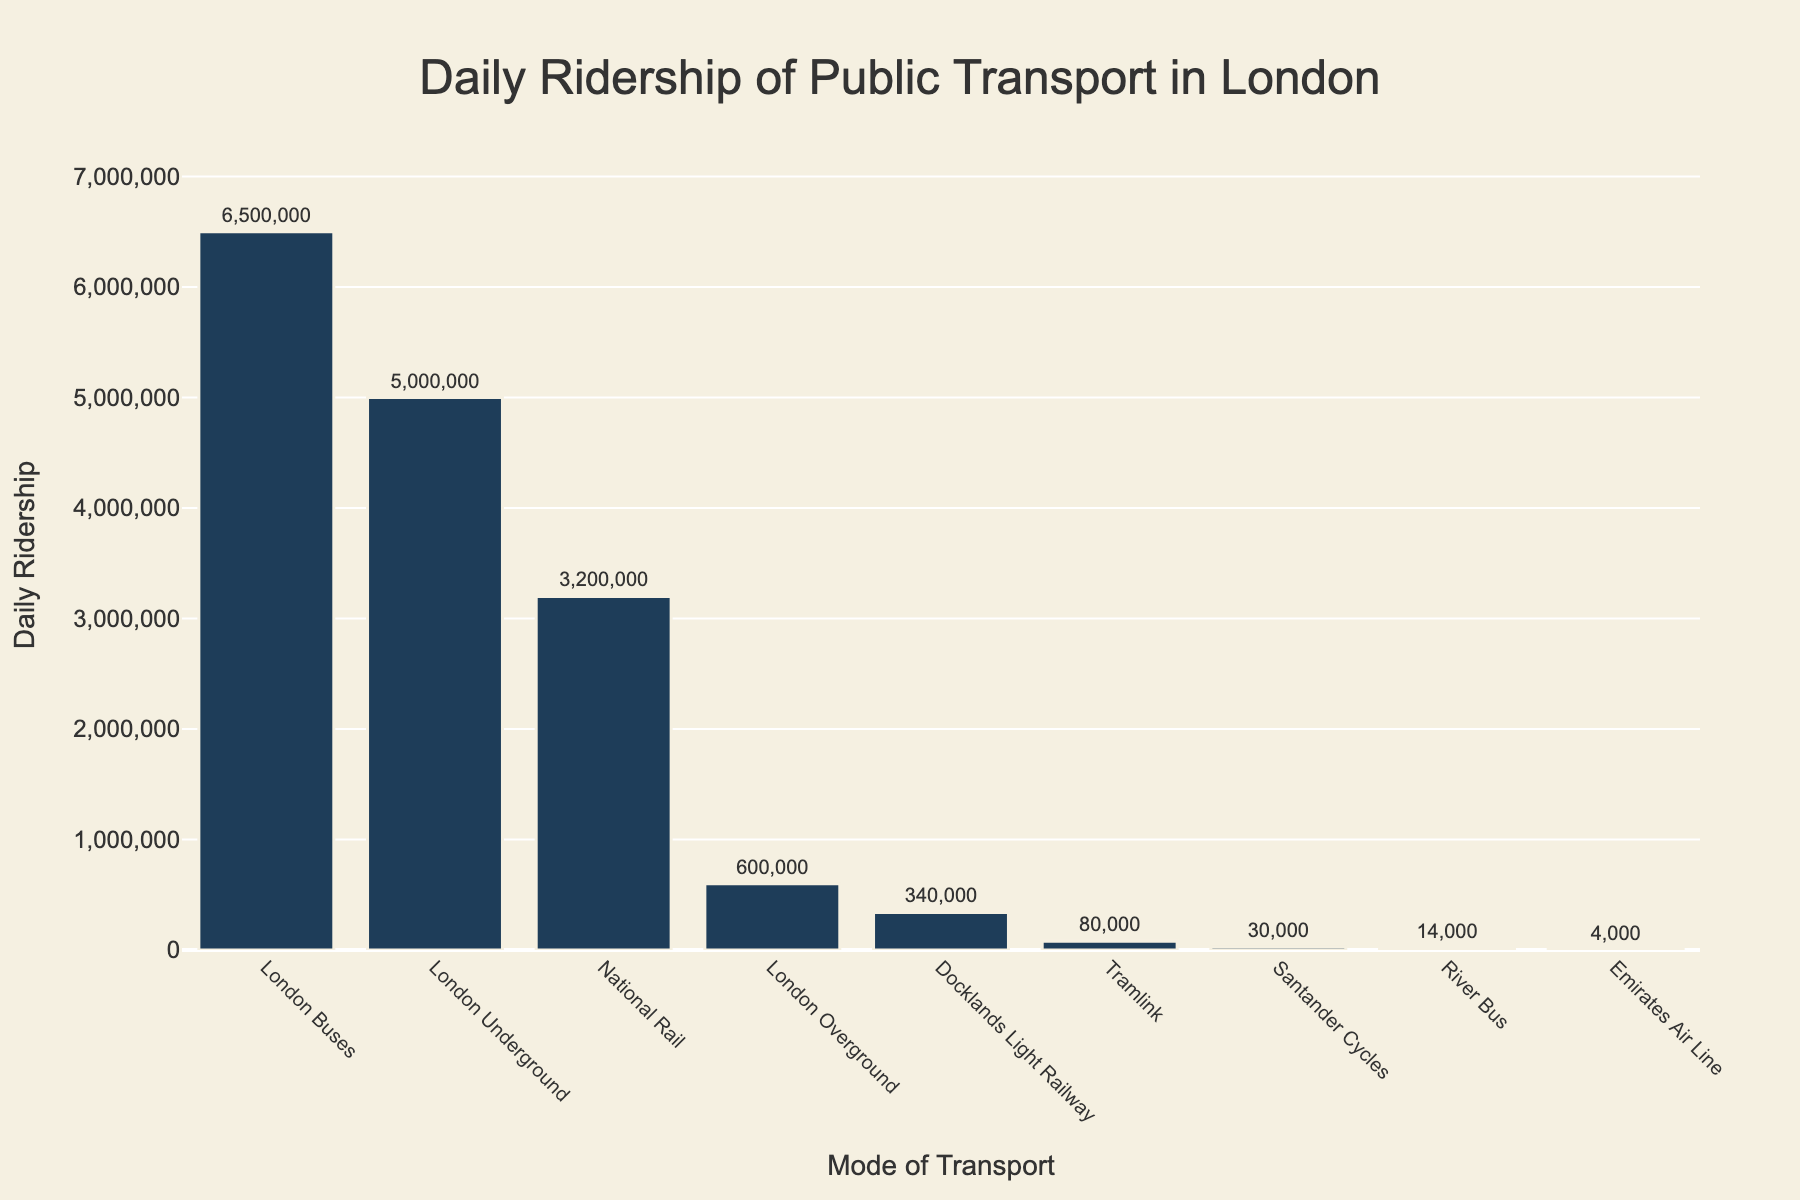What is the daily ridership of London Buses? To answer this, simply refer to the bar labeled "London Buses" and check the text on top of it, which indicates the daily ridership.
Answer: 6,500,000 Which mode of transport has the lowest daily ridership? Look for the shortest bar on the chart, as it represents the mode of transport with the lowest daily ridership.
Answer: Emirates Air Line What is the total daily ridership of the top three modes of transport combined? Identify the top three modes by height of their bars, then sum up the riderships of these modes: London Buses (6,500,000), London Underground (5,000,000), and National Rail (3,200,000). Therefore, 6,500,000 + 5,000,000 + 3,200,000 = 14,700,000.
Answer: 14,700,000 Is the daily ridership of the Docklands Light Railway greater than that of the London Overground? Compare the heights of the bars for Docklands Light Railway and London Overground. The Docklands Light Railway has a higher value, which exceeds the London Overground's ridership.
Answer: Yes What’s the difference in daily ridership between the highest and the lowest mode of transport? Identify the highest and lowest daily riderships: London Buses (6,500,000) and Emirates Air Line (4,000). The difference is 6,500,000 - 4,000 = 6,496,000.
Answer: 6,496,000 How many more people use London Buses compared to Santander Cycles daily? Refer to the bars for London Buses and Santander Cycles, then subtract the daily ridership of Santander Cycles from London Buses: 6,500,000 - 30,000 = 6,470,000.
Answer: 6,470,000 Which transport modes have a daily ridership of less than 100,000? Identify the bars that represent transport modes with ridership less than 100,000: Tramlink (80,000), River Bus (14,000), and Emirates Air Line (4,000).
Answer: Tramlink, River Bus, Emirates Air Line Is the combined daily ridership of Tramlink, River Bus, and Emirates Air Line greater than that of the London Overground? First, sum up the ridership of Tramlink (80,000), River Bus (14,000), and Emirates Air Line (4,000): 80,000 + 14,000 + 4,000 = 98,000. Then compare this with London Overground (600,000). Since 98,000 < 600,000, it is not greater.
Answer: No Which two modes of transport have daily riderships closest to each other? Compare the bars of different transport modes and find the pair with the smallest difference: National Rail (3,200,000) and Docklands Light Railway (340,000) differ significantly from others, but close ones are London Overground (600,000) and Docklands Light Railway (340,000), differing by 260,000.
Answer: London Overground, Docklands Light Railway 